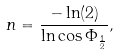Convert formula to latex. <formula><loc_0><loc_0><loc_500><loc_500>n = \frac { - \ln ( 2 ) } { \ln \cos { \Phi _ { \frac { 1 } { 2 } } } } ,</formula> 